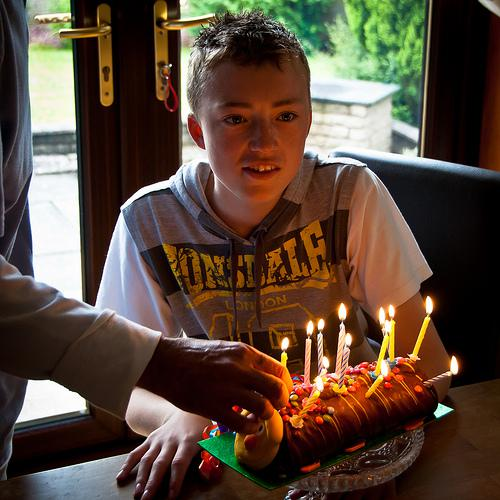Question: what is chocolate?
Choices:
A. Pudding.
B. Cupcakes.
C. Cake.
D. Ice cream.
Answer with the letter. Answer: C Question: what is lit?
Choices:
A. Bonfire.
B. Neon sign.
C. Storefront.
D. Candles.
Answer with the letter. Answer: D Question: what is green?
Choices:
A. Grass.
B. Cars.
C. Trees outside.
D. Building.
Answer with the letter. Answer: C 